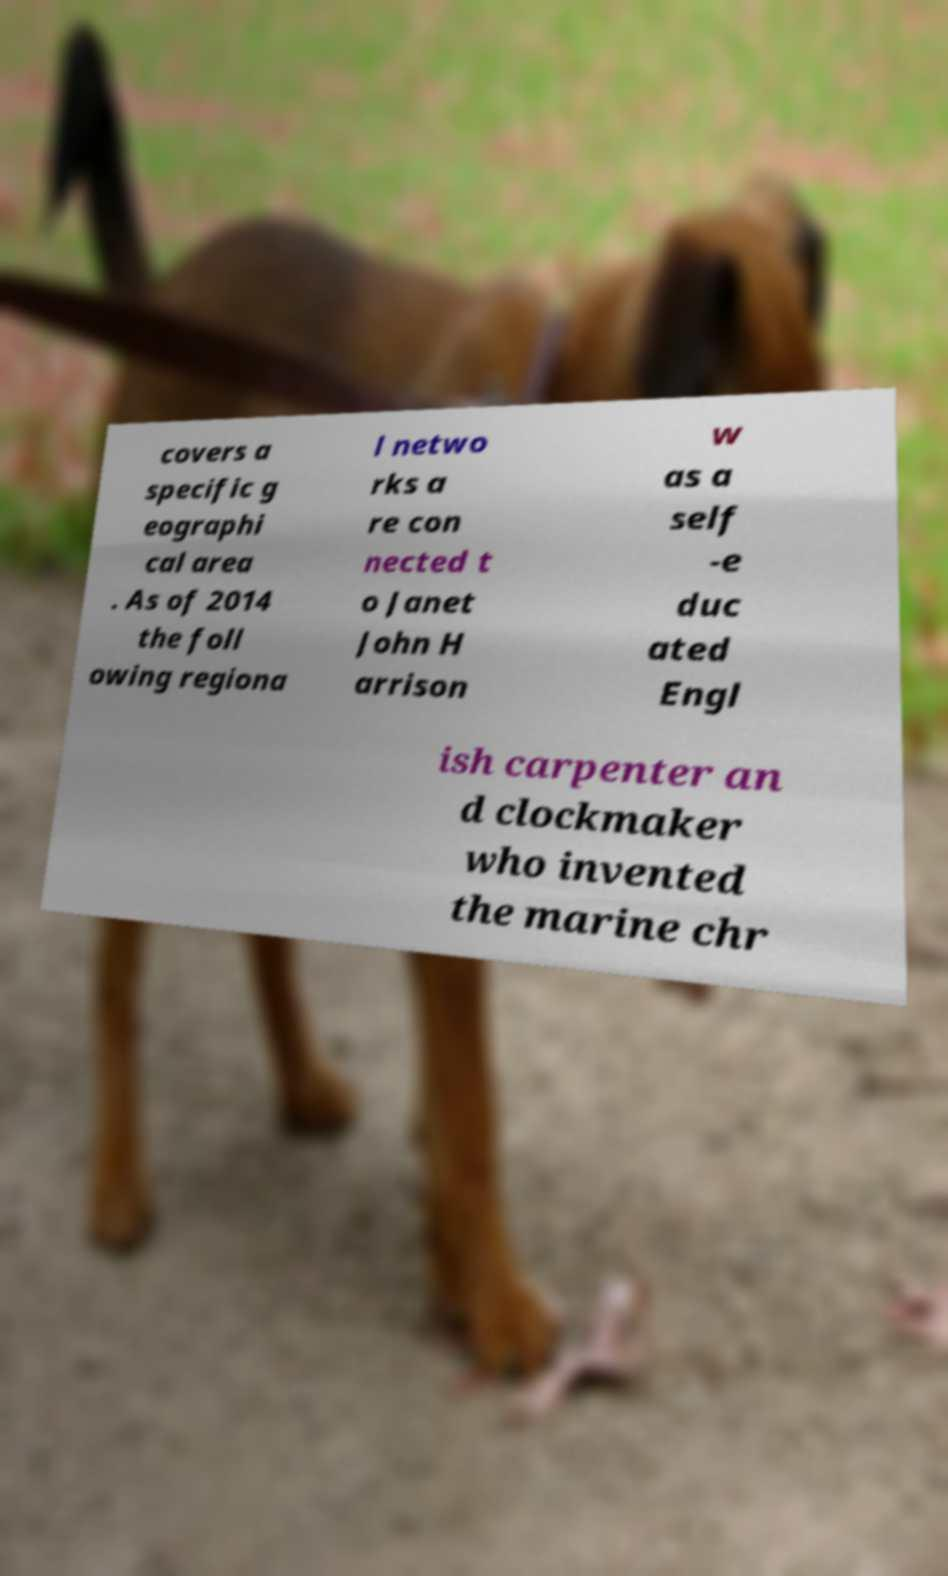Could you extract and type out the text from this image? covers a specific g eographi cal area . As of 2014 the foll owing regiona l netwo rks a re con nected t o Janet John H arrison w as a self -e duc ated Engl ish carpenter an d clockmaker who invented the marine chr 